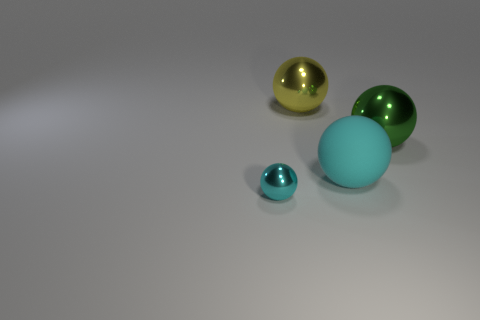What size is the object that is the same color as the tiny sphere?
Your answer should be compact. Large. What is the size of the green ball?
Give a very brief answer. Large. How many yellow objects have the same size as the green metallic thing?
Make the answer very short. 1. There is another cyan thing that is the same shape as the small cyan metallic object; what is its material?
Your answer should be very brief. Rubber. What is the shape of the big thing that is in front of the large yellow thing and behind the matte sphere?
Make the answer very short. Sphere. There is a big metallic thing that is in front of the large yellow sphere; what is its shape?
Provide a succinct answer. Sphere. What number of objects are in front of the large rubber thing and on the right side of the small cyan shiny object?
Ensure brevity in your answer.  0. Does the green thing have the same size as the cyan sphere to the right of the yellow thing?
Your response must be concise. Yes. What is the size of the thing that is behind the metal object on the right side of the large yellow thing on the left side of the large green metal thing?
Your response must be concise. Large. There is a metallic sphere that is right of the big yellow ball; what is its size?
Your answer should be compact. Large. 